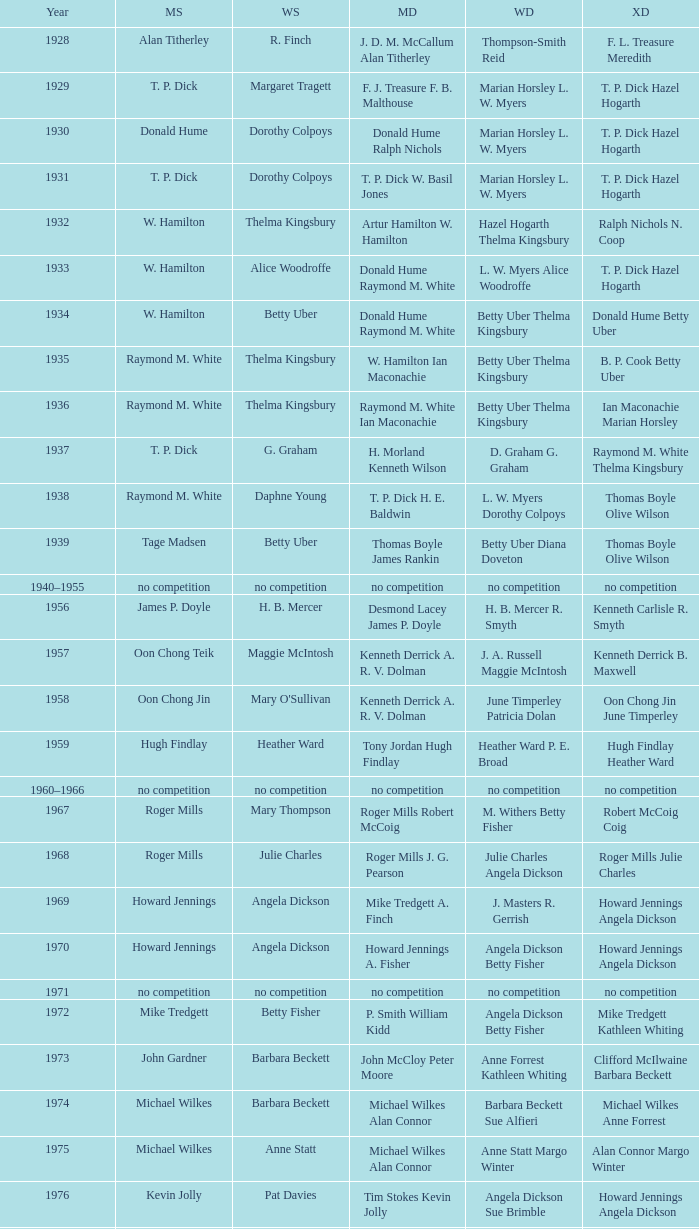Parse the full table. {'header': ['Year', 'MS', 'WS', 'MD', 'WD', 'XD'], 'rows': [['1928', 'Alan Titherley', 'R. Finch', 'J. D. M. McCallum Alan Titherley', 'Thompson-Smith Reid', 'F. L. Treasure Meredith'], ['1929', 'T. P. Dick', 'Margaret Tragett', 'F. J. Treasure F. B. Malthouse', 'Marian Horsley L. W. Myers', 'T. P. Dick Hazel Hogarth'], ['1930', 'Donald Hume', 'Dorothy Colpoys', 'Donald Hume Ralph Nichols', 'Marian Horsley L. W. Myers', 'T. P. Dick Hazel Hogarth'], ['1931', 'T. P. Dick', 'Dorothy Colpoys', 'T. P. Dick W. Basil Jones', 'Marian Horsley L. W. Myers', 'T. P. Dick Hazel Hogarth'], ['1932', 'W. Hamilton', 'Thelma Kingsbury', 'Artur Hamilton W. Hamilton', 'Hazel Hogarth Thelma Kingsbury', 'Ralph Nichols N. Coop'], ['1933', 'W. Hamilton', 'Alice Woodroffe', 'Donald Hume Raymond M. White', 'L. W. Myers Alice Woodroffe', 'T. P. Dick Hazel Hogarth'], ['1934', 'W. Hamilton', 'Betty Uber', 'Donald Hume Raymond M. White', 'Betty Uber Thelma Kingsbury', 'Donald Hume Betty Uber'], ['1935', 'Raymond M. White', 'Thelma Kingsbury', 'W. Hamilton Ian Maconachie', 'Betty Uber Thelma Kingsbury', 'B. P. Cook Betty Uber'], ['1936', 'Raymond M. White', 'Thelma Kingsbury', 'Raymond M. White Ian Maconachie', 'Betty Uber Thelma Kingsbury', 'Ian Maconachie Marian Horsley'], ['1937', 'T. P. Dick', 'G. Graham', 'H. Morland Kenneth Wilson', 'D. Graham G. Graham', 'Raymond M. White Thelma Kingsbury'], ['1938', 'Raymond M. White', 'Daphne Young', 'T. P. Dick H. E. Baldwin', 'L. W. Myers Dorothy Colpoys', 'Thomas Boyle Olive Wilson'], ['1939', 'Tage Madsen', 'Betty Uber', 'Thomas Boyle James Rankin', 'Betty Uber Diana Doveton', 'Thomas Boyle Olive Wilson'], ['1940–1955', 'no competition', 'no competition', 'no competition', 'no competition', 'no competition'], ['1956', 'James P. Doyle', 'H. B. Mercer', 'Desmond Lacey James P. Doyle', 'H. B. Mercer R. Smyth', 'Kenneth Carlisle R. Smyth'], ['1957', 'Oon Chong Teik', 'Maggie McIntosh', 'Kenneth Derrick A. R. V. Dolman', 'J. A. Russell Maggie McIntosh', 'Kenneth Derrick B. Maxwell'], ['1958', 'Oon Chong Jin', "Mary O'Sullivan", 'Kenneth Derrick A. R. V. Dolman', 'June Timperley Patricia Dolan', 'Oon Chong Jin June Timperley'], ['1959', 'Hugh Findlay', 'Heather Ward', 'Tony Jordan Hugh Findlay', 'Heather Ward P. E. Broad', 'Hugh Findlay Heather Ward'], ['1960–1966', 'no competition', 'no competition', 'no competition', 'no competition', 'no competition'], ['1967', 'Roger Mills', 'Mary Thompson', 'Roger Mills Robert McCoig', 'M. Withers Betty Fisher', 'Robert McCoig Coig'], ['1968', 'Roger Mills', 'Julie Charles', 'Roger Mills J. G. Pearson', 'Julie Charles Angela Dickson', 'Roger Mills Julie Charles'], ['1969', 'Howard Jennings', 'Angela Dickson', 'Mike Tredgett A. Finch', 'J. Masters R. Gerrish', 'Howard Jennings Angela Dickson'], ['1970', 'Howard Jennings', 'Angela Dickson', 'Howard Jennings A. Fisher', 'Angela Dickson Betty Fisher', 'Howard Jennings Angela Dickson'], ['1971', 'no competition', 'no competition', 'no competition', 'no competition', 'no competition'], ['1972', 'Mike Tredgett', 'Betty Fisher', 'P. Smith William Kidd', 'Angela Dickson Betty Fisher', 'Mike Tredgett Kathleen Whiting'], ['1973', 'John Gardner', 'Barbara Beckett', 'John McCloy Peter Moore', 'Anne Forrest Kathleen Whiting', 'Clifford McIlwaine Barbara Beckett'], ['1974', 'Michael Wilkes', 'Barbara Beckett', 'Michael Wilkes Alan Connor', 'Barbara Beckett Sue Alfieri', 'Michael Wilkes Anne Forrest'], ['1975', 'Michael Wilkes', 'Anne Statt', 'Michael Wilkes Alan Connor', 'Anne Statt Margo Winter', 'Alan Connor Margo Winter'], ['1976', 'Kevin Jolly', 'Pat Davies', 'Tim Stokes Kevin Jolly', 'Angela Dickson Sue Brimble', 'Howard Jennings Angela Dickson'], ['1977', 'David Eddy', 'Paula Kilvington', 'David Eddy Eddy Sutton', 'Anne Statt Jane Webster', 'David Eddy Barbara Giles'], ['1978', 'Mike Tredgett', 'Gillian Gilks', 'David Eddy Eddy Sutton', 'Barbara Sutton Marjan Ridder', 'Elliot Stuart Gillian Gilks'], ['1979', 'Kevin Jolly', 'Nora Perry', 'Ray Stevens Mike Tredgett', 'Barbara Sutton Nora Perry', 'Mike Tredgett Nora Perry'], ['1980', 'Thomas Kihlström', 'Jane Webster', 'Thomas Kihlström Bengt Fröman', 'Jane Webster Karen Puttick', 'Billy Gilliland Karen Puttick'], ['1981', 'Ray Stevens', 'Gillian Gilks', 'Ray Stevens Mike Tredgett', 'Gillian Gilks Paula Kilvington', 'Mike Tredgett Nora Perry'], ['1982', 'Steve Baddeley', 'Karen Bridge', 'David Eddy Eddy Sutton', 'Karen Chapman Sally Podger', 'Billy Gilliland Karen Chapman'], ['1983', 'Steve Butler', 'Sally Podger', 'Mike Tredgett Dipak Tailor', 'Nora Perry Jane Webster', 'Dipak Tailor Nora Perry'], ['1984', 'Steve Butler', 'Karen Beckman', 'Mike Tredgett Martin Dew', 'Helen Troke Karen Chapman', 'Mike Tredgett Karen Chapman'], ['1985', 'Morten Frost', 'Charlotte Hattens', 'Billy Gilliland Dan Travers', 'Gillian Gilks Helen Troke', 'Martin Dew Gillian Gilks'], ['1986', 'Darren Hall', 'Fiona Elliott', 'Martin Dew Dipak Tailor', 'Karen Beckman Sara Halsall', 'Jesper Knudsen Nettie Nielsen'], ['1987', 'Darren Hall', 'Fiona Elliott', 'Martin Dew Darren Hall', 'Karen Beckman Sara Halsall', 'Martin Dew Gillian Gilks'], ['1988', 'Vimal Kumar', 'Lee Jung-mi', 'Richard Outterside Mike Brown', 'Fiona Elliott Sara Halsall', 'Martin Dew Gillian Gilks'], ['1989', 'Darren Hall', 'Bang Soo-hyun', 'Nick Ponting Dave Wright', 'Karen Beckman Sara Sankey', 'Mike Brown Jillian Wallwork'], ['1990', 'Mathew Smith', 'Joanne Muggeridge', 'Nick Ponting Dave Wright', 'Karen Chapman Sara Sankey', 'Dave Wright Claire Palmer'], ['1991', 'Vimal Kumar', 'Denyse Julien', 'Nick Ponting Dave Wright', 'Cheryl Johnson Julie Bradbury', 'Nick Ponting Joanne Wright'], ['1992', 'Wei Yan', 'Fiona Smith', 'Michael Adams Chris Rees', 'Denyse Julien Doris Piché', 'Andy Goode Joanne Wright'], ['1993', 'Anders Nielsen', 'Sue Louis Lane', 'Nick Ponting Dave Wright', 'Julie Bradbury Sara Sankey', 'Nick Ponting Joanne Wright'], ['1994', 'Darren Hall', 'Marina Andrievskaya', 'Michael Adams Simon Archer', 'Julie Bradbury Joanne Wright', 'Chris Hunt Joanne Wright'], ['1995', 'Peter Rasmussen', 'Denyse Julien', 'Andrei Andropov Nikolai Zuyev', 'Julie Bradbury Joanne Wright', 'Nick Ponting Joanne Wright'], ['1996', 'Colin Haughton', 'Elena Rybkina', 'Andrei Andropov Nikolai Zuyev', 'Elena Rybkina Marina Yakusheva', 'Nikolai Zuyev Marina Yakusheva'], ['1997', 'Chris Bruil', 'Kelly Morgan', 'Ian Pearson James Anderson', 'Nicole van Hooren Brenda Conijn', 'Quinten van Dalm Nicole van Hooren'], ['1998', 'Dicky Palyama', 'Brenda Beenhakker', 'James Anderson Ian Sullivan', 'Sara Sankey Ella Tripp', 'James Anderson Sara Sankey'], ['1999', 'Daniel Eriksson', 'Marina Andrievskaya', 'Joachim Tesche Jean-Philippe Goyette', 'Marina Andrievskaya Catrine Bengtsson', 'Henrik Andersson Marina Andrievskaya'], ['2000', 'Richard Vaughan', 'Marina Yakusheva', 'Joachim Andersson Peter Axelsson', 'Irina Ruslyakova Marina Yakusheva', 'Peter Jeffrey Joanne Davies'], ['2001', 'Irwansyah', 'Brenda Beenhakker', 'Vincent Laigle Svetoslav Stoyanov', 'Sara Sankey Ella Tripp', 'Nikolai Zuyev Marina Yakusheva'], ['2002', 'Irwansyah', 'Karina de Wit', 'Nikolai Zuyev Stanislav Pukhov', 'Ella Tripp Joanne Wright', 'Nikolai Zuyev Marina Yakusheva'], ['2003', 'Irwansyah', 'Ella Karachkova', 'Ashley Thilthorpe Kristian Roebuck', 'Ella Karachkova Anastasia Russkikh', 'Alexandr Russkikh Anastasia Russkikh'], ['2004', 'Nathan Rice', 'Petya Nedelcheva', 'Reuben Gordown Aji Basuki Sindoro', 'Petya Nedelcheva Yuan Wemyss', 'Matthew Hughes Kelly Morgan'], ['2005', 'Chetan Anand', 'Eleanor Cox', 'Andrew Ellis Dean George', 'Hayley Connor Heather Olver', 'Valiyaveetil Diju Jwala Gutta'], ['2006', 'Irwansyah', 'Huang Chia-chi', 'Matthew Hughes Martyn Lewis', 'Natalie Munt Mariana Agathangelou', 'Kristian Roebuck Natalie Munt'], ['2007', 'Marc Zwiebler', 'Jill Pittard', 'Wojciech Szkudlarczyk Adam Cwalina', 'Chloe Magee Bing Huang', 'Wojciech Szkudlarczyk Malgorzata Kurdelska'], ['2008', 'Brice Leverdez', 'Kati Tolmoff', 'Andrew Bowman Martyn Lewis', 'Mariana Agathangelou Jillie Cooper', 'Watson Briggs Jillie Cooper'], ['2009', 'Kristian Nielsen', 'Tatjana Bibik', 'Vitaliy Durkin Alexandr Nikolaenko', 'Valeria Sorokina Nina Vislova', 'Vitaliy Durkin Nina Vislova'], ['2010', 'Pablo Abián', 'Anita Raj Kaur', 'Peter Käsbauer Josche Zurwonne', 'Joanne Quay Swee Ling Anita Raj Kaur', 'Peter Käsbauer Johanna Goliszewski'], ['2011', 'Niluka Karunaratne', 'Nicole Schaller', 'Chris Coles Matthew Nottingham', 'Ng Hui Ern Ng Hui Lin', 'Martin Campbell Ng Hui Lin'], ['2012', 'Chou Tien-chen', 'Chiang Mei-hui', 'Marcus Ellis Paul Van Rietvelde', 'Gabrielle White Lauren Smith', 'Marcus Ellis Gabrielle White']]} Who was the men's singles champion in the year ian maconachie marian horsley secured the mixed doubles title? Raymond M. White. 